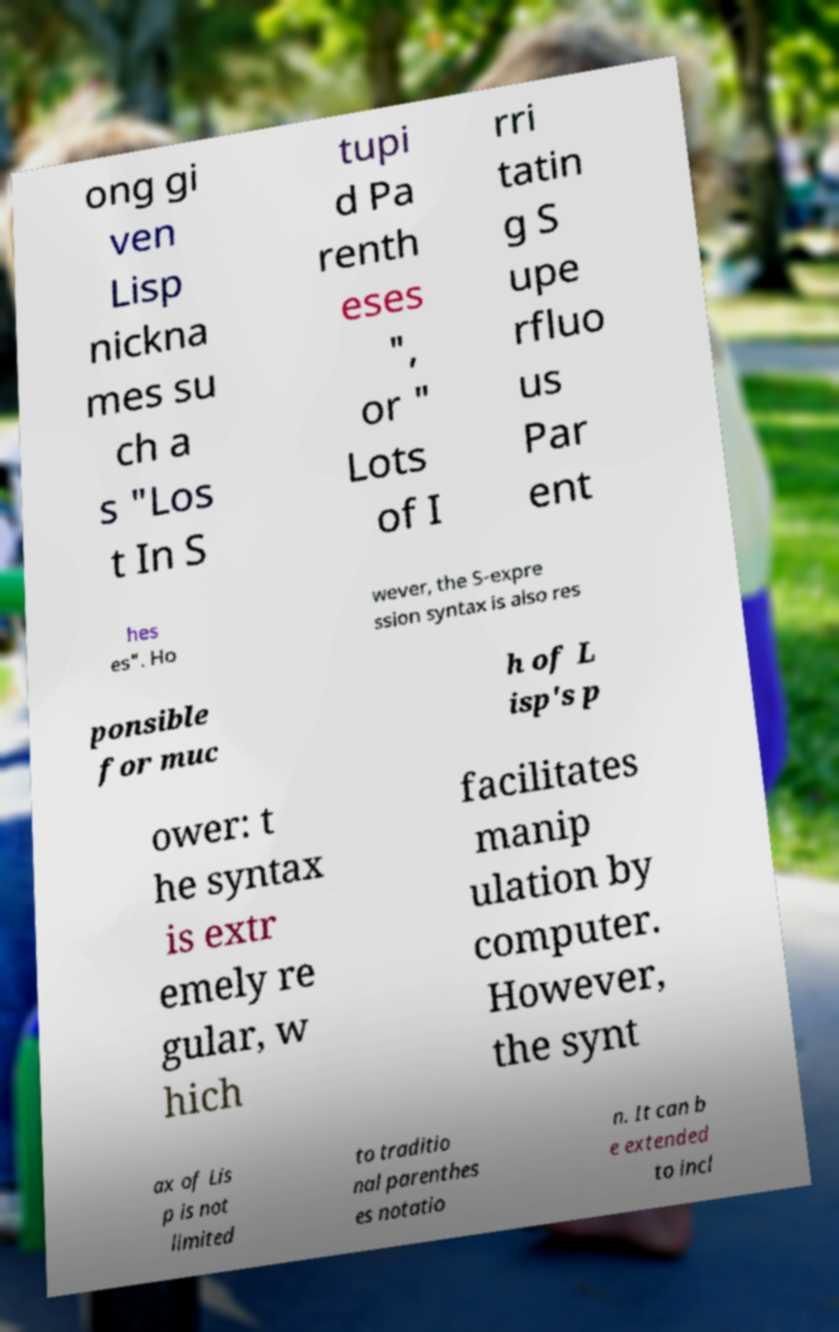Please read and relay the text visible in this image. What does it say? ong gi ven Lisp nickna mes su ch a s "Los t In S tupi d Pa renth eses ", or " Lots of I rri tatin g S upe rfluo us Par ent hes es". Ho wever, the S-expre ssion syntax is also res ponsible for muc h of L isp's p ower: t he syntax is extr emely re gular, w hich facilitates manip ulation by computer. However, the synt ax of Lis p is not limited to traditio nal parenthes es notatio n. It can b e extended to incl 